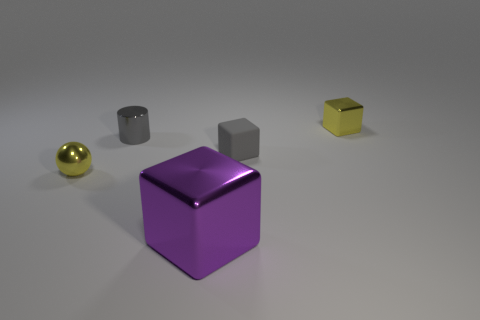Add 4 big purple objects. How many objects exist? 9 Subtract all cubes. How many objects are left? 2 Add 4 tiny shiny things. How many tiny shiny things are left? 7 Add 4 spheres. How many spheres exist? 5 Subtract 0 purple spheres. How many objects are left? 5 Subtract all tiny shiny cylinders. Subtract all small yellow cubes. How many objects are left? 3 